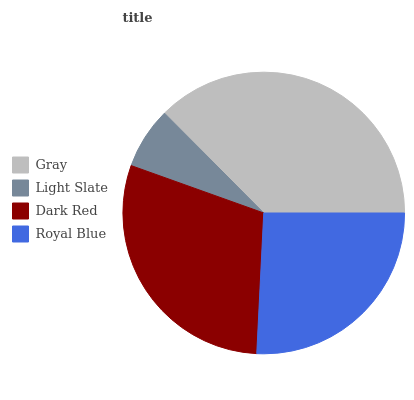Is Light Slate the minimum?
Answer yes or no. Yes. Is Gray the maximum?
Answer yes or no. Yes. Is Dark Red the minimum?
Answer yes or no. No. Is Dark Red the maximum?
Answer yes or no. No. Is Dark Red greater than Light Slate?
Answer yes or no. Yes. Is Light Slate less than Dark Red?
Answer yes or no. Yes. Is Light Slate greater than Dark Red?
Answer yes or no. No. Is Dark Red less than Light Slate?
Answer yes or no. No. Is Dark Red the high median?
Answer yes or no. Yes. Is Royal Blue the low median?
Answer yes or no. Yes. Is Royal Blue the high median?
Answer yes or no. No. Is Light Slate the low median?
Answer yes or no. No. 